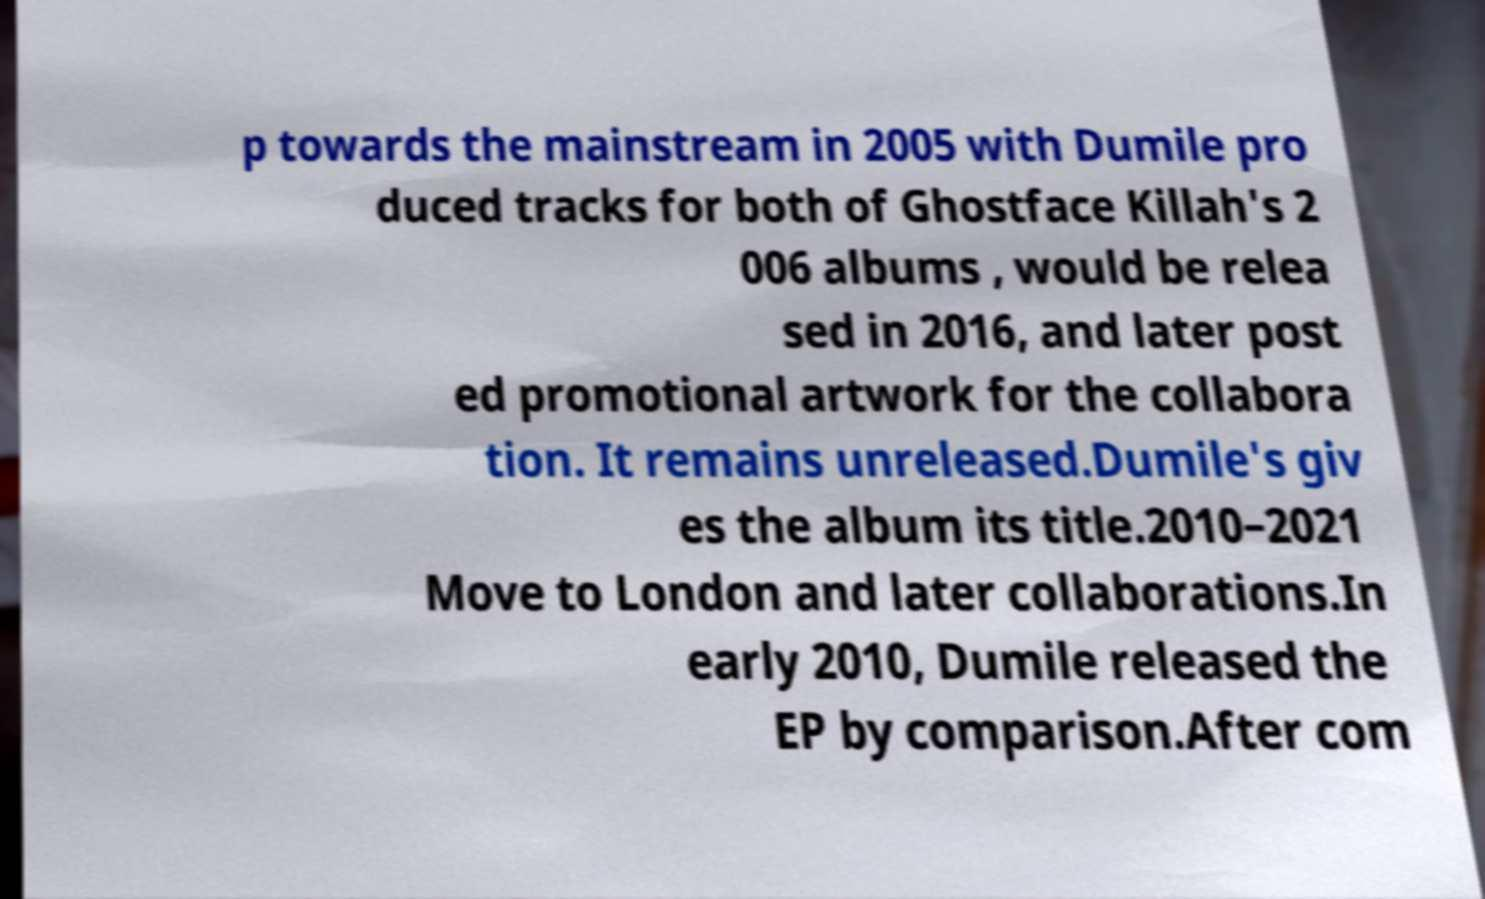Please identify and transcribe the text found in this image. p towards the mainstream in 2005 with Dumile pro duced tracks for both of Ghostface Killah's 2 006 albums , would be relea sed in 2016, and later post ed promotional artwork for the collabora tion. It remains unreleased.Dumile's giv es the album its title.2010–2021 Move to London and later collaborations.In early 2010, Dumile released the EP by comparison.After com 